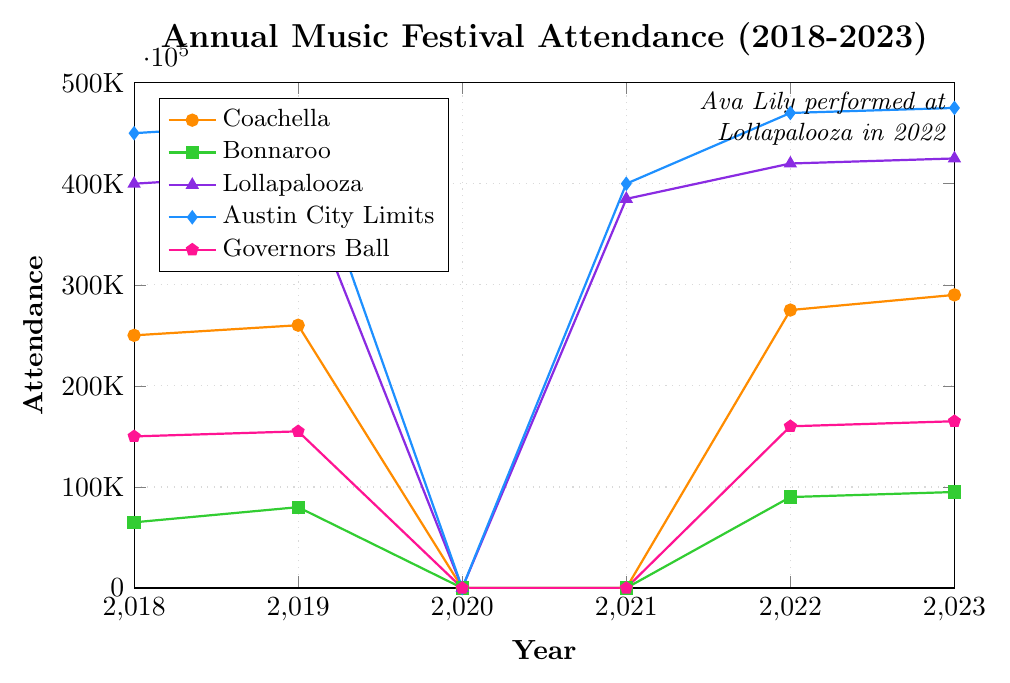What is the trend in attendance for Coachella from 2018 to 2023? Attendance at Coachella shows an upward trend over the years, starting at 250,000 in 2018, increasing to 260,000 in 2019, and then rising to 275,000 in 2022 and 290,000 in 2023. There was no attendance in 2020 and 2021.
Answer: Upward trend In which year did Lollapalooza have the lowest attendance? By examining the plot for the line corresponding to Lollapalooza, the lowest attendance is observed in 2021 with 385,000 attendees.
Answer: 2021 How does the attendance of Austin City Limits in 2023 compare to that of Governors Ball in the same year? The plot shows that Austin City Limits had an attendance of 475,000 in 2023, while Governors Ball had 165,000 attendees. Comparatively, Austin City Limits had a higher attendance.
Answer: Austin City Limits had higher attendance How many festivals had zero attendance in 2020? By looking at the attendance values for all festivals in 2020, Coachella, Bonnaroo, Lollapalooza, Austin City Limits, and Governors Ball all had zero attendance.
Answer: 5 festivals What was the total attendance for all festivals in 2019? By summing the attendance numbers for all festivals in 2019, we get 260,000 (Coachella) + 80,000 (Bonnaroo) + 410,000 (Lollapalooza) + 460,000 (Austin City Limits) + 155,000 (Governors Ball) = 1,365,000 attendees.
Answer: 1,365,000 Which festival experienced the highest increase in attendance from 2022 to 2023 and by how much? The increases from 2022 to 2023 are calculated as follows: Coachella (+15,000), Bonnaroo (+5,000), Lollapalooza (+5,000), Austin City Limits (+5,000), and Governors Ball (+5,000). Coachella experienced the highest increase of 15,000 attendees.
Answer: Coachella, 15,000 How does the trend for Bonnaroo compare to that of Governors Ball from 2018 to 2023? Both festivals had no attendees in 2020 and 2021. However, Bonnaroo shows a progressive increase in attendance from 65,000 in 2018 to 95,000 in 2023, whereas Governors Ball increased more moderately from 150,000 in 2018 to 165,000 in 2023.
Answer: Bonnaroo has a steeper increasing trend What is the average attendance for Lollapalooza over the years? Sum the attendance for Lollapalooza over the years provided (exclude 0 attendance years), which is 400,000 (2018) + 410,000 (2019) + 385,000 (2021) + 420,000 (2022) + 425,000 (2023) = 2,040,000. Divide this sum by the number of years with attendance data (5), so 2,040,000 / 5 = 408,000.
Answer: 408,000 Identify which year's attendance data for Austin City Limits is marked with a diamond-shaped marker and explain what this signifies visually compared to other markers. The diamond-shaped marker represents the years 2018 to 2023 for Austin City Limits. Visually, it differentiates Austin City Limits from other festivals which use different shapes like circles, squares, triangles, and pentagons.
Answer: Years 2018 to 2023 